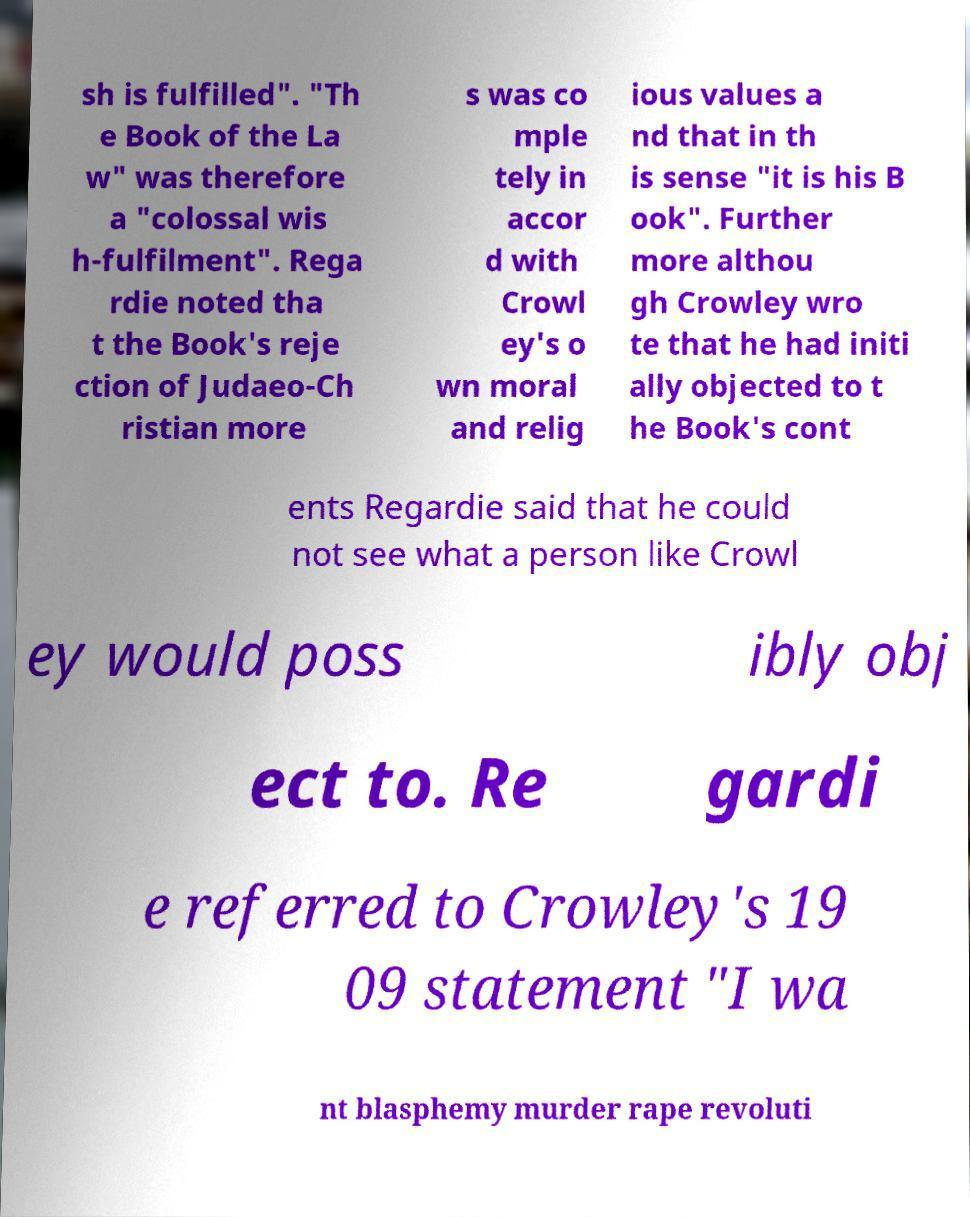Could you assist in decoding the text presented in this image and type it out clearly? sh is fulfilled". "Th e Book of the La w" was therefore a "colossal wis h-fulfilment". Rega rdie noted tha t the Book's reje ction of Judaeo-Ch ristian more s was co mple tely in accor d with Crowl ey's o wn moral and relig ious values a nd that in th is sense "it is his B ook". Further more althou gh Crowley wro te that he had initi ally objected to t he Book's cont ents Regardie said that he could not see what a person like Crowl ey would poss ibly obj ect to. Re gardi e referred to Crowley's 19 09 statement "I wa nt blasphemy murder rape revoluti 